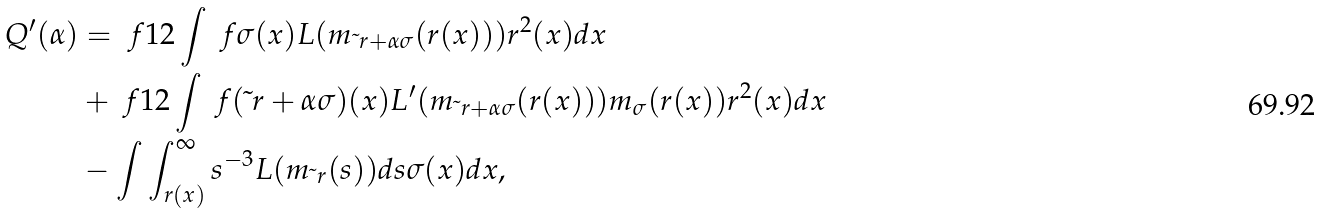Convert formula to latex. <formula><loc_0><loc_0><loc_500><loc_500>Q ^ { \prime } ( \alpha ) & = \ f { 1 } { 2 } \int \ f { \sigma ( x ) L ( m _ { \tilde { \ } r + \alpha \sigma } ( r ( x ) ) ) } { r ^ { 2 } ( x ) } d x \\ & + \ f { 1 } { 2 } \int \ f { ( \tilde { \ } r + \alpha \sigma ) ( x ) L ^ { \prime } ( m _ { \tilde { \ } r + \alpha \sigma } ( r ( x ) ) ) m _ { \sigma } ( r ( x ) ) } { r ^ { 2 } ( x ) } d x \\ & - \int \int _ { r ( x ) } ^ { \infty } s ^ { - 3 } L ( m _ { \tilde { \ } r } ( s ) ) d s \sigma ( x ) d x ,</formula> 